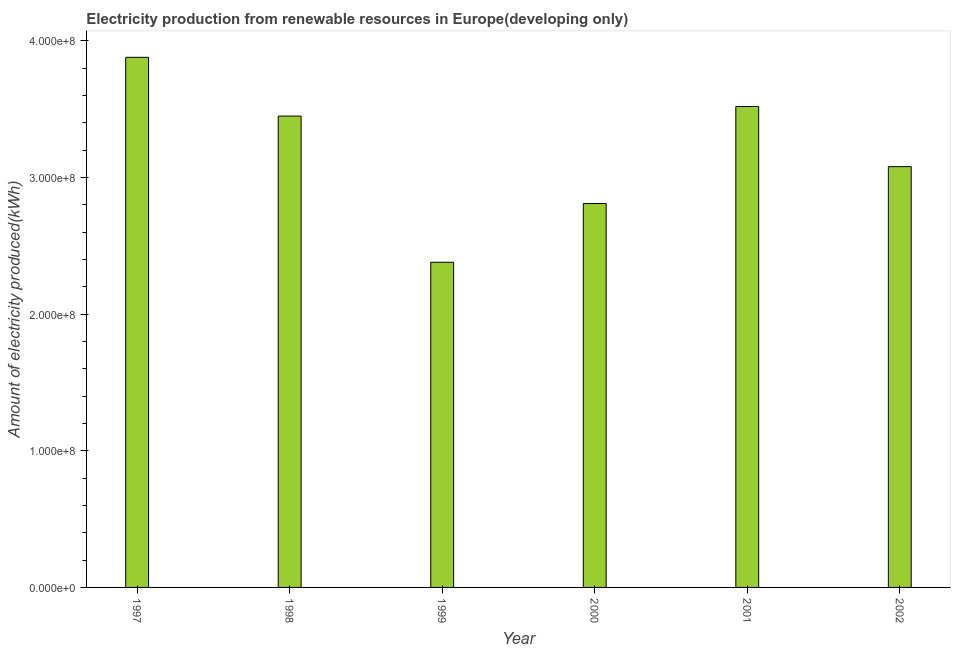Does the graph contain any zero values?
Keep it short and to the point. No. Does the graph contain grids?
Provide a succinct answer. No. What is the title of the graph?
Give a very brief answer. Electricity production from renewable resources in Europe(developing only). What is the label or title of the X-axis?
Ensure brevity in your answer.  Year. What is the label or title of the Y-axis?
Give a very brief answer. Amount of electricity produced(kWh). What is the amount of electricity produced in 2002?
Ensure brevity in your answer.  3.08e+08. Across all years, what is the maximum amount of electricity produced?
Your answer should be compact. 3.88e+08. Across all years, what is the minimum amount of electricity produced?
Provide a short and direct response. 2.38e+08. In which year was the amount of electricity produced maximum?
Give a very brief answer. 1997. What is the sum of the amount of electricity produced?
Offer a terse response. 1.91e+09. What is the difference between the amount of electricity produced in 2000 and 2001?
Provide a short and direct response. -7.10e+07. What is the average amount of electricity produced per year?
Keep it short and to the point. 3.19e+08. What is the median amount of electricity produced?
Provide a short and direct response. 3.26e+08. Do a majority of the years between 1998 and 1997 (inclusive) have amount of electricity produced greater than 140000000 kWh?
Your response must be concise. No. What is the ratio of the amount of electricity produced in 1997 to that in 1998?
Make the answer very short. 1.12. What is the difference between the highest and the second highest amount of electricity produced?
Your answer should be compact. 3.60e+07. Is the sum of the amount of electricity produced in 1999 and 2000 greater than the maximum amount of electricity produced across all years?
Your response must be concise. Yes. What is the difference between the highest and the lowest amount of electricity produced?
Your answer should be very brief. 1.50e+08. In how many years, is the amount of electricity produced greater than the average amount of electricity produced taken over all years?
Make the answer very short. 3. How many years are there in the graph?
Offer a terse response. 6. What is the difference between two consecutive major ticks on the Y-axis?
Your answer should be very brief. 1.00e+08. What is the Amount of electricity produced(kWh) in 1997?
Your answer should be compact. 3.88e+08. What is the Amount of electricity produced(kWh) of 1998?
Your answer should be very brief. 3.45e+08. What is the Amount of electricity produced(kWh) of 1999?
Ensure brevity in your answer.  2.38e+08. What is the Amount of electricity produced(kWh) of 2000?
Keep it short and to the point. 2.81e+08. What is the Amount of electricity produced(kWh) in 2001?
Offer a terse response. 3.52e+08. What is the Amount of electricity produced(kWh) of 2002?
Ensure brevity in your answer.  3.08e+08. What is the difference between the Amount of electricity produced(kWh) in 1997 and 1998?
Your answer should be compact. 4.30e+07. What is the difference between the Amount of electricity produced(kWh) in 1997 and 1999?
Your answer should be very brief. 1.50e+08. What is the difference between the Amount of electricity produced(kWh) in 1997 and 2000?
Offer a terse response. 1.07e+08. What is the difference between the Amount of electricity produced(kWh) in 1997 and 2001?
Give a very brief answer. 3.60e+07. What is the difference between the Amount of electricity produced(kWh) in 1997 and 2002?
Offer a very short reply. 8.00e+07. What is the difference between the Amount of electricity produced(kWh) in 1998 and 1999?
Offer a terse response. 1.07e+08. What is the difference between the Amount of electricity produced(kWh) in 1998 and 2000?
Provide a succinct answer. 6.40e+07. What is the difference between the Amount of electricity produced(kWh) in 1998 and 2001?
Keep it short and to the point. -7.00e+06. What is the difference between the Amount of electricity produced(kWh) in 1998 and 2002?
Make the answer very short. 3.70e+07. What is the difference between the Amount of electricity produced(kWh) in 1999 and 2000?
Offer a very short reply. -4.30e+07. What is the difference between the Amount of electricity produced(kWh) in 1999 and 2001?
Ensure brevity in your answer.  -1.14e+08. What is the difference between the Amount of electricity produced(kWh) in 1999 and 2002?
Your answer should be very brief. -7.00e+07. What is the difference between the Amount of electricity produced(kWh) in 2000 and 2001?
Provide a succinct answer. -7.10e+07. What is the difference between the Amount of electricity produced(kWh) in 2000 and 2002?
Provide a succinct answer. -2.70e+07. What is the difference between the Amount of electricity produced(kWh) in 2001 and 2002?
Ensure brevity in your answer.  4.40e+07. What is the ratio of the Amount of electricity produced(kWh) in 1997 to that in 1998?
Your answer should be compact. 1.12. What is the ratio of the Amount of electricity produced(kWh) in 1997 to that in 1999?
Offer a terse response. 1.63. What is the ratio of the Amount of electricity produced(kWh) in 1997 to that in 2000?
Provide a succinct answer. 1.38. What is the ratio of the Amount of electricity produced(kWh) in 1997 to that in 2001?
Offer a very short reply. 1.1. What is the ratio of the Amount of electricity produced(kWh) in 1997 to that in 2002?
Your answer should be very brief. 1.26. What is the ratio of the Amount of electricity produced(kWh) in 1998 to that in 1999?
Provide a short and direct response. 1.45. What is the ratio of the Amount of electricity produced(kWh) in 1998 to that in 2000?
Offer a very short reply. 1.23. What is the ratio of the Amount of electricity produced(kWh) in 1998 to that in 2002?
Keep it short and to the point. 1.12. What is the ratio of the Amount of electricity produced(kWh) in 1999 to that in 2000?
Your response must be concise. 0.85. What is the ratio of the Amount of electricity produced(kWh) in 1999 to that in 2001?
Provide a succinct answer. 0.68. What is the ratio of the Amount of electricity produced(kWh) in 1999 to that in 2002?
Give a very brief answer. 0.77. What is the ratio of the Amount of electricity produced(kWh) in 2000 to that in 2001?
Your response must be concise. 0.8. What is the ratio of the Amount of electricity produced(kWh) in 2000 to that in 2002?
Offer a terse response. 0.91. What is the ratio of the Amount of electricity produced(kWh) in 2001 to that in 2002?
Keep it short and to the point. 1.14. 